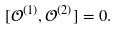Convert formula to latex. <formula><loc_0><loc_0><loc_500><loc_500>[ \mathcal { O } ^ { ( 1 ) } , \mathcal { O } ^ { ( 2 ) } ] = 0 .</formula> 